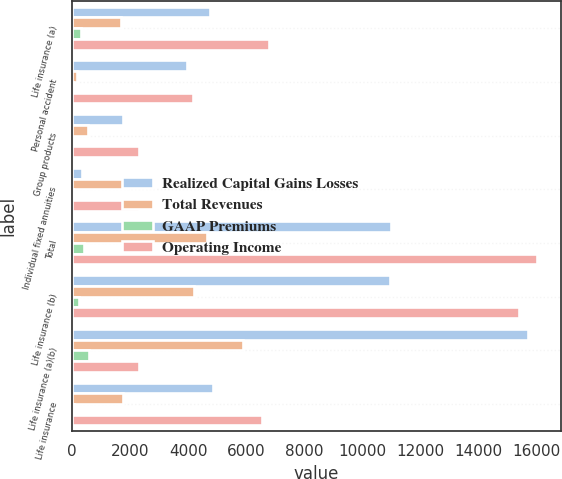<chart> <loc_0><loc_0><loc_500><loc_500><stacked_bar_chart><ecel><fcel>Life insurance (a)<fcel>Personal accident<fcel>Group products<fcel>Individual fixed annuities<fcel>Total<fcel>Life insurance (b)<fcel>Life insurance (a)(b)<fcel>Life insurance<nl><fcel>Realized Capital Gains Losses<fcel>4769<fcel>3957<fcel>1740<fcel>337<fcel>10976<fcel>10949<fcel>15718<fcel>4852<nl><fcel>Total Revenues<fcel>1696<fcel>162<fcel>541<fcel>1930<fcel>4654<fcel>4188<fcel>5884<fcel>1752<nl><fcel>GAAP Premiums<fcel>316<fcel>49<fcel>13<fcel>28<fcel>406<fcel>258<fcel>574<fcel>52<nl><fcel>Operating Income<fcel>6781<fcel>4168<fcel>2294<fcel>2295<fcel>16036<fcel>15395<fcel>2294<fcel>6552<nl></chart> 